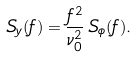Convert formula to latex. <formula><loc_0><loc_0><loc_500><loc_500>S _ { y } ( f ) = \frac { f ^ { 2 } } { \nu _ { 0 } ^ { 2 } } \, S _ { \phi } ( f ) .</formula> 